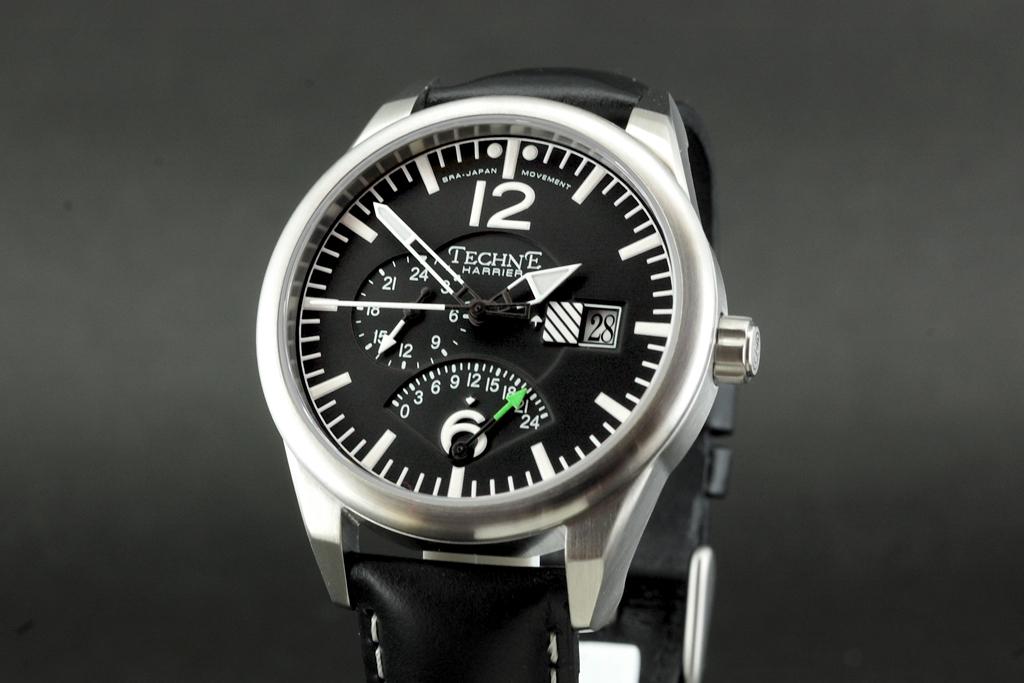What brand of watch is this?
Your answer should be very brief. Techne. What is the large number?
Offer a very short reply. 12. 